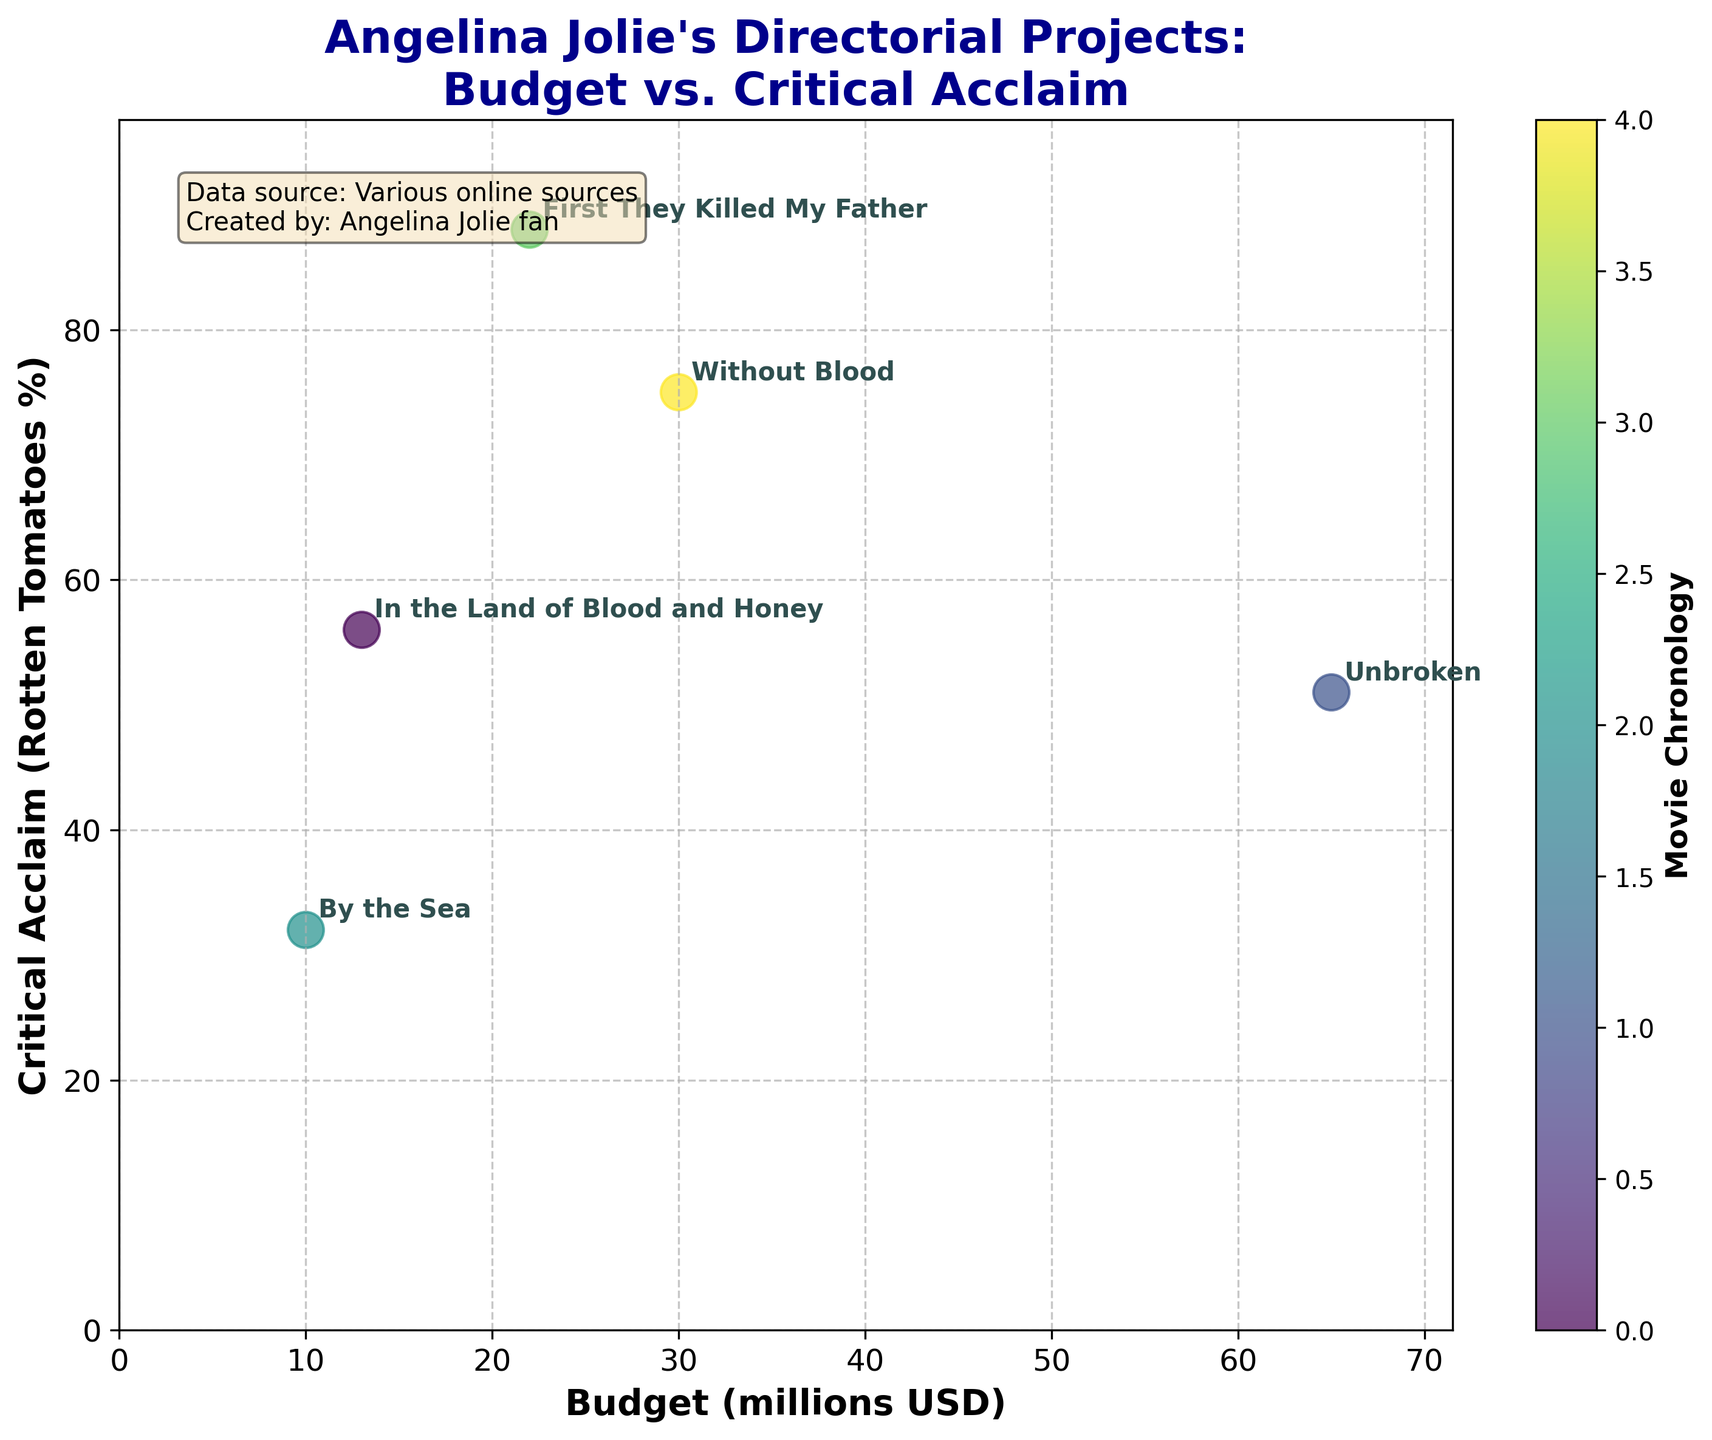How many movies are represented in the plot? By counting the number of labeled dots on the scatter plot, we can determine that there are 5 movies shown.
Answer: 5 Which movie had the highest critical acclaim and what was its Rotten Tomatoes percentage? By examining the y-axis, which represents Critical Acclaim (Rotten Tomatoes %), the movie "First They Killed My Father" is highest on the plot with an 88% rating.
Answer: "First They Killed My Father" with 88% What is the title of the plot? The title of the plot is displayed at the top of the figure and reads "Angelina Jolie's Directorial Projects: Budget vs. Critical Acclaim".
Answer: Angelina Jolie's Directorial Projects: Budget vs. Critical Acclaim Which movie had the smallest budget, and how much was it? By looking at the x-axis, which represents the budget in millions of USD, "By the Sea" has the lowest value at 10 million USD.
Answer: "By the Sea" with 10 million USD Compare "Unbroken" and "In the Land of Blood and Honey" in terms of budget. Which one had a higher budget and by how much? "Unbroken" had a budget of 65 million USD, while "In the Land of Blood and Honey" had 13 million USD. Subtracting these gives 65 - 13 = 52 million USD.
Answer: "Unbroken" by 52 million USD Which movie is closest to having both an average budget and average critical acclaim score? First, calculate the average budget and critical acclaim: Budget average = (13+65+10+22+30)/5 = 28 million USD, Critical acclaim average = (56+51+32+88+75)/5 = 60.4%. The movie "Without Blood" with a budget of 30 million USD and 75% critical acclaim is closest to both averages.
Answer: "Without Blood" Between "By the Sea" and "First They Killed My Father", which movie received a higher critical acclaim and what are their respective percentages? "First They Killed My Father" received 88%, which is higher than "By the Sea" at 32%.
Answer: "First They Killed My Father" with 88%, "By the Sea" with 32% Which movie could be considered the best budget-friendly option based on its balance of budget and critical acclaim? "Without Blood" stands out with a moderate budget of 30 million USD and a high critical acclaim of 75%, making it a budget-friendly option with significant acclaim.
Answer: "Without Blood" How does "Unbroken" rank in terms of budget and critical acclaim relative to the other movies? "Unbroken" has the highest budget at 65 million USD but a relatively low critical acclaim of 51%, placing it high in budget but low in critical acclaim compared to the others.
Answer: Highest in budget, low in critical acclaim Compare the critical acclaim of "Without Blood" and "In the Land of Blood and Honey". Which movie had better reviews and by how much? "Without Blood" had a critical acclaim of 75% whereas "In the Land of Blood and Honey" had 56%. The difference is 75 - 56 = 19%.
Answer: "Without Blood" by 19% 